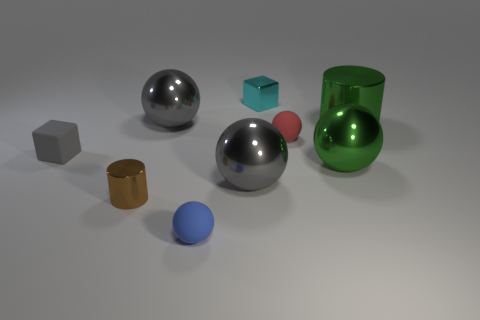Can you describe the placement of the red object in relation to the green glass? The red sphere is placed in front of the green glass, slightly closer to the left side if you're looking straight at the image. How many objects are there that have a reflective surface? There are five objects with a reflective surface: two metallic spheres, a green glass, a cyan cube, and a metallic cylinder. 